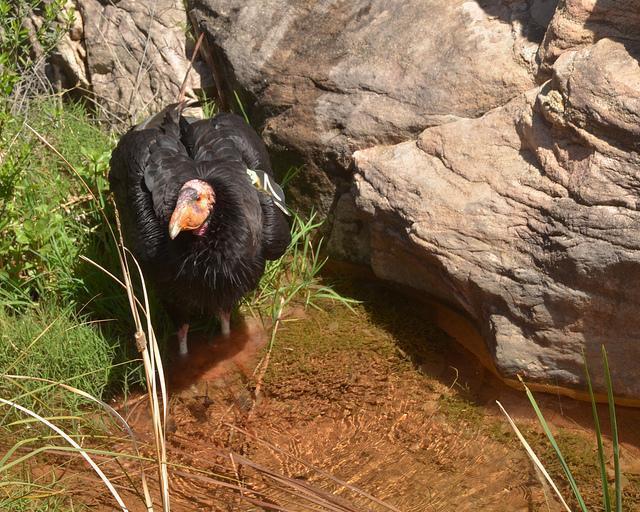How many people are wearing red shirts?
Give a very brief answer. 0. 